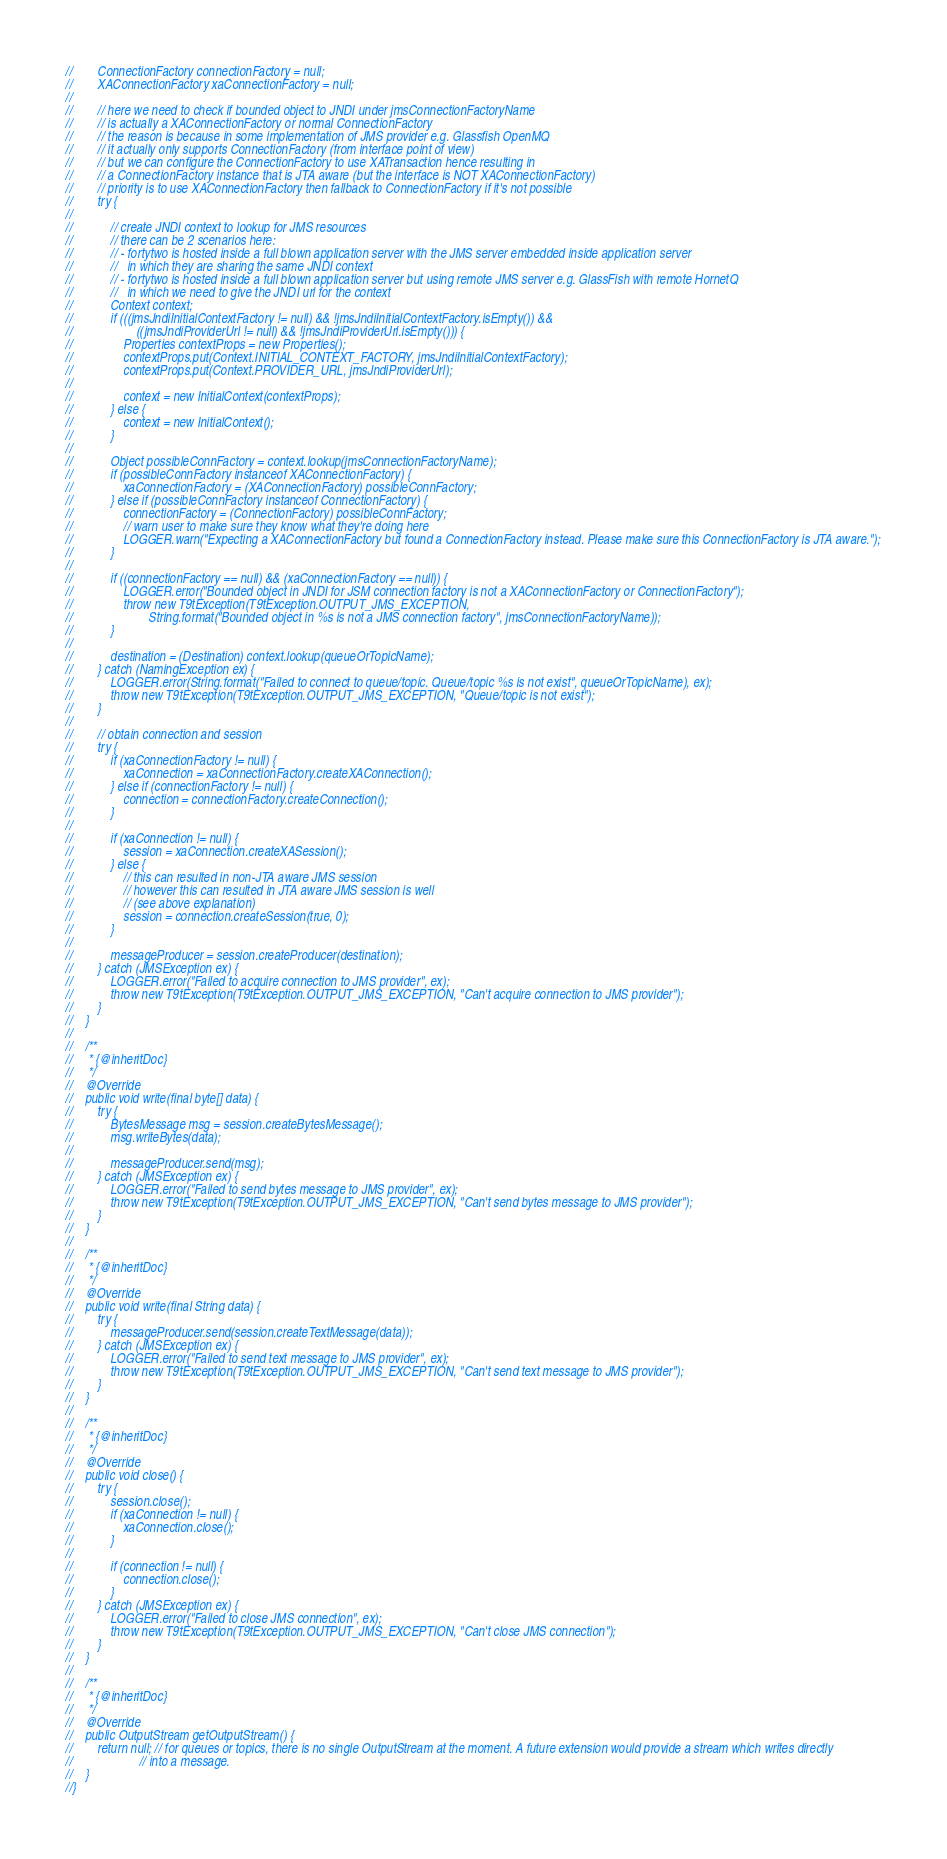<code> <loc_0><loc_0><loc_500><loc_500><_Java_>//        ConnectionFactory connectionFactory = null;
//        XAConnectionFactory xaConnectionFactory = null;
//
//        // here we need to check if bounded object to JNDI under jmsConnectionFactoryName
//        // is actually a XAConnectionFactory or normal ConnectionFactory
//        // the reason is because in some implementation of JMS provider e.g. Glassfish OpenMQ
//        // it actually only supports ConnectionFactory (from interface point of view)
//        // but we can configure the ConnectionFactory to use XATransaction hence resulting in
//        // a ConnectionFactory instance that is JTA aware (but the interface is NOT XAConnectionFactory)
//        // priority is to use XAConnectionFactory then fallback to ConnectionFactory if it's not possible
//        try {
//
//            // create JNDI context to lookup for JMS resources
//            // there can be 2 scenarios here:
//            // - fortytwo is hosted inside a full blown application server with the JMS server embedded inside application server
//            //   in which they are sharing the same JNDI context
//            // - fortytwo is hosted inside a full blown application server but using remote JMS server e.g. GlassFish with remote HornetQ
//            //   in which we need to give the JNDI url for the context
//            Context context;
//            if (((jmsJndiInitialContextFactory != null) && !jmsJndiInitialContextFactory.isEmpty()) &&
//                    ((jmsJndiProviderUrl != null) && !jmsJndiProviderUrl.isEmpty())) {
//                Properties contextProps = new Properties();
//                contextProps.put(Context.INITIAL_CONTEXT_FACTORY, jmsJndiInitialContextFactory);
//                contextProps.put(Context.PROVIDER_URL, jmsJndiProviderUrl);
//
//                context = new InitialContext(contextProps);
//            } else {
//                context = new InitialContext();
//            }
//
//            Object possibleConnFactory = context.lookup(jmsConnectionFactoryName);
//            if (possibleConnFactory instanceof XAConnectionFactory) {
//                xaConnectionFactory = (XAConnectionFactory) possibleConnFactory;
//            } else if (possibleConnFactory instanceof ConnectionFactory) {
//                connectionFactory = (ConnectionFactory) possibleConnFactory;
//                // warn user to make sure they know what they're doing here
//                LOGGER.warn("Expecting a XAConnectionFactory but found a ConnectionFactory instead. Please make sure this ConnectionFactory is JTA aware.");
//            }
//
//            if ((connectionFactory == null) && (xaConnectionFactory == null)) {
//                LOGGER.error("Bounded object in JNDI for JSM connection factory is not a XAConnectionFactory or ConnectionFactory");
//                throw new T9tException(T9tException.OUTPUT_JMS_EXCEPTION,
//                        String.format("Bounded object in %s is not a JMS connection factory", jmsConnectionFactoryName));
//            }
//
//            destination = (Destination) context.lookup(queueOrTopicName);
//        } catch (NamingException ex) {
//            LOGGER.error(String.format("Failed to connect to queue/topic. Queue/topic %s is not exist", queueOrTopicName), ex);
//            throw new T9tException(T9tException.OUTPUT_JMS_EXCEPTION, "Queue/topic is not exist");
//        }
//
//        // obtain connection and session
//        try {
//            if (xaConnectionFactory != null) {
//                xaConnection = xaConnectionFactory.createXAConnection();
//            } else if (connectionFactory != null) {
//                connection = connectionFactory.createConnection();
//            }
//
//            if (xaConnection != null) {
//                session = xaConnection.createXASession();
//            } else {
//                // this can resulted in non-JTA aware JMS session
//                // however this can resulted in JTA aware JMS session is well
//                // (see above explanation)
//                session = connection.createSession(true, 0);
//            }
//
//            messageProducer = session.createProducer(destination);
//        } catch (JMSException ex) {
//            LOGGER.error("Failed to acquire connection to JMS provider", ex);
//            throw new T9tException(T9tException.OUTPUT_JMS_EXCEPTION, "Can't acquire connection to JMS provider");
//        }
//    }
//
//    /**
//     * {@inheritDoc}
//     */
//    @Override
//    public void write(final byte[] data) {
//        try {
//            BytesMessage msg = session.createBytesMessage();
//            msg.writeBytes(data);
//
//            messageProducer.send(msg);
//        } catch (JMSException ex) {
//            LOGGER.error("Failed to send bytes message to JMS provider", ex);
//            throw new T9tException(T9tException.OUTPUT_JMS_EXCEPTION, "Can't send bytes message to JMS provider");
//        }
//    }
//
//    /**
//     * {@inheritDoc}
//     */
//    @Override
//    public void write(final String data) {
//        try {
//            messageProducer.send(session.createTextMessage(data));
//        } catch (JMSException ex) {
//            LOGGER.error("Failed to send text message to JMS provider", ex);
//            throw new T9tException(T9tException.OUTPUT_JMS_EXCEPTION, "Can't send text message to JMS provider");
//        }
//    }
//
//    /**
//     * {@inheritDoc}
//     */
//    @Override
//    public void close() {
//        try {
//            session.close();
//            if (xaConnection != null) {
//                xaConnection.close();
//            }
//
//            if (connection != null) {
//                connection.close();
//            }
//        } catch (JMSException ex) {
//            LOGGER.error("Failed to close JMS connection", ex);
//            throw new T9tException(T9tException.OUTPUT_JMS_EXCEPTION, "Can't close JMS connection");
//        }
//    }
//
//    /**
//     * {@inheritDoc}
//     */
//    @Override
//    public OutputStream getOutputStream() {
//        return null; // for queues or topics, there is no single OutputStream at the moment. A future extension would provide a stream which writes directly
//                     // into a message.
//    }
//}
</code> 